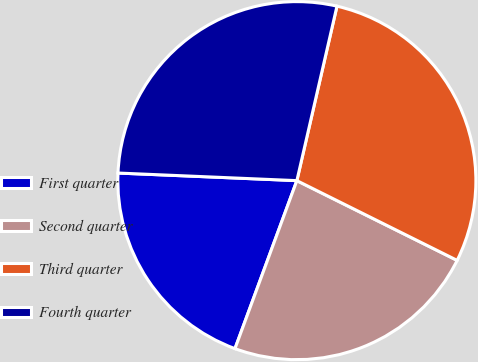Convert chart to OTSL. <chart><loc_0><loc_0><loc_500><loc_500><pie_chart><fcel>First quarter<fcel>Second quarter<fcel>Third quarter<fcel>Fourth quarter<nl><fcel>20.06%<fcel>23.27%<fcel>28.75%<fcel>27.92%<nl></chart> 